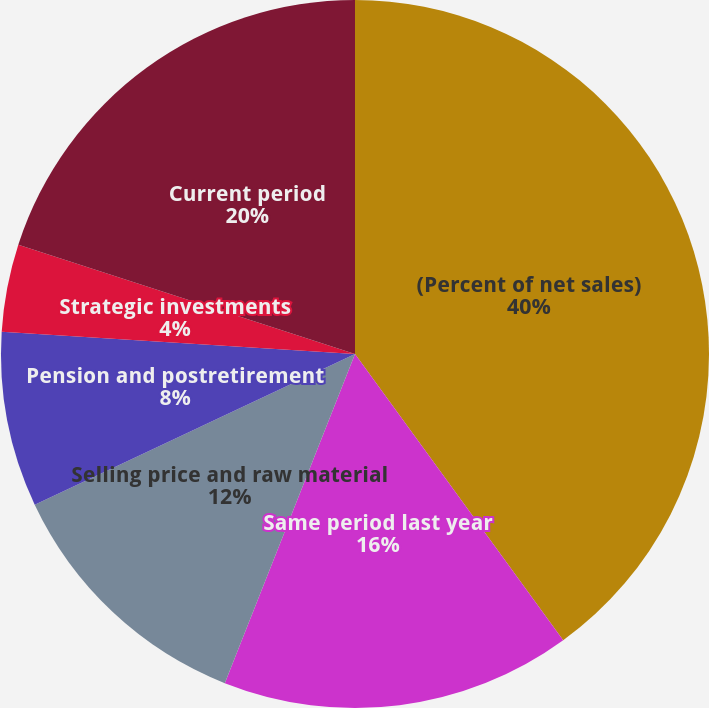Convert chart. <chart><loc_0><loc_0><loc_500><loc_500><pie_chart><fcel>(Percent of net sales)<fcel>Same period last year<fcel>Selling price and raw material<fcel>Pension and postretirement<fcel>Acquisitions and divestitures<fcel>Strategic investments<fcel>Current period<nl><fcel>39.99%<fcel>16.0%<fcel>12.0%<fcel>8.0%<fcel>0.0%<fcel>4.0%<fcel>20.0%<nl></chart> 